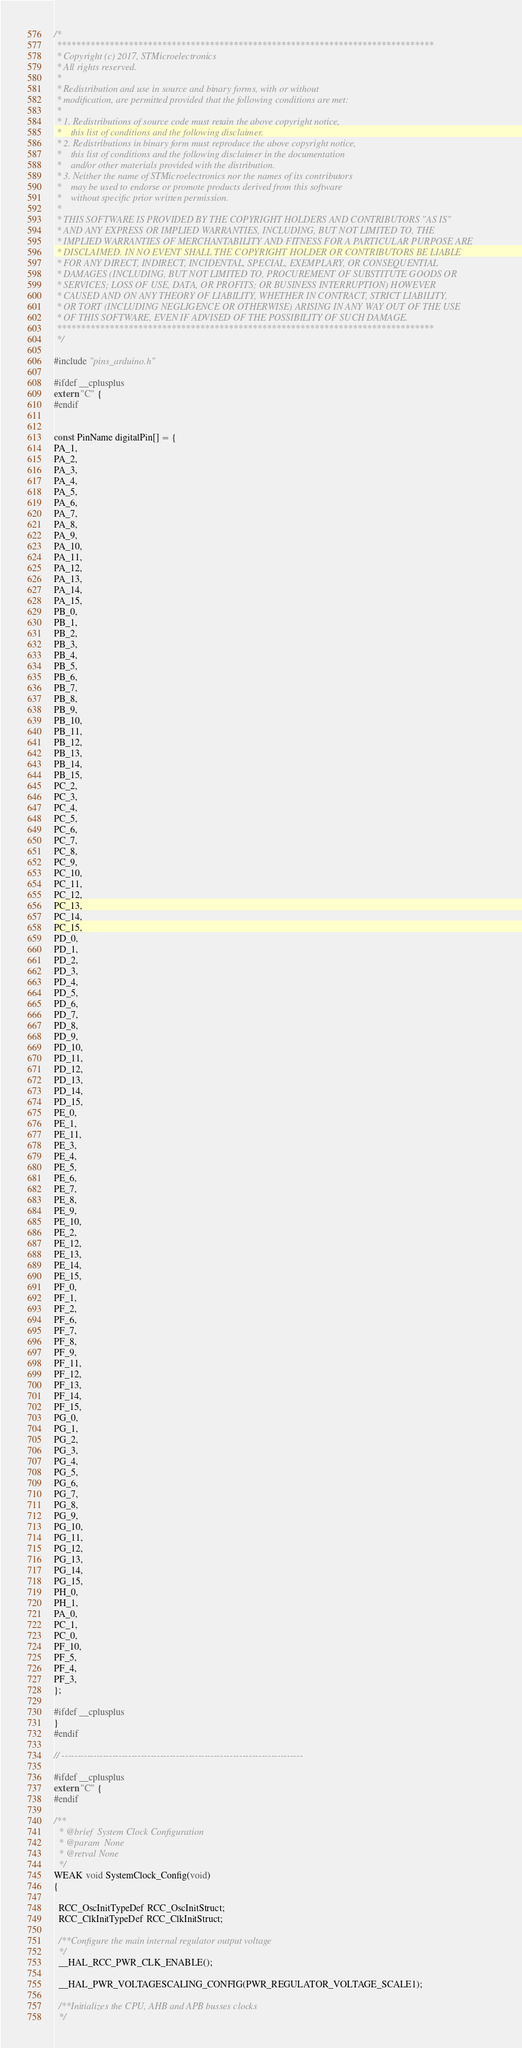<code> <loc_0><loc_0><loc_500><loc_500><_C++_>/*
 *******************************************************************************
 * Copyright (c) 2017, STMicroelectronics
 * All rights reserved.
 *
 * Redistribution and use in source and binary forms, with or without
 * modification, are permitted provided that the following conditions are met:
 *
 * 1. Redistributions of source code must retain the above copyright notice,
 *    this list of conditions and the following disclaimer.
 * 2. Redistributions in binary form must reproduce the above copyright notice,
 *    this list of conditions and the following disclaimer in the documentation
 *    and/or other materials provided with the distribution.
 * 3. Neither the name of STMicroelectronics nor the names of its contributors
 *    may be used to endorse or promote products derived from this software
 *    without specific prior written permission.
 *
 * THIS SOFTWARE IS PROVIDED BY THE COPYRIGHT HOLDERS AND CONTRIBUTORS "AS IS"
 * AND ANY EXPRESS OR IMPLIED WARRANTIES, INCLUDING, BUT NOT LIMITED TO, THE
 * IMPLIED WARRANTIES OF MERCHANTABILITY AND FITNESS FOR A PARTICULAR PURPOSE ARE
 * DISCLAIMED. IN NO EVENT SHALL THE COPYRIGHT HOLDER OR CONTRIBUTORS BE LIABLE
 * FOR ANY DIRECT, INDIRECT, INCIDENTAL, SPECIAL, EXEMPLARY, OR CONSEQUENTIAL
 * DAMAGES (INCLUDING, BUT NOT LIMITED TO, PROCUREMENT OF SUBSTITUTE GOODS OR
 * SERVICES; LOSS OF USE, DATA, OR PROFITS; OR BUSINESS INTERRUPTION) HOWEVER
 * CAUSED AND ON ANY THEORY OF LIABILITY, WHETHER IN CONTRACT, STRICT LIABILITY,
 * OR TORT (INCLUDING NEGLIGENCE OR OTHERWISE) ARISING IN ANY WAY OUT OF THE USE
 * OF THIS SOFTWARE, EVEN IF ADVISED OF THE POSSIBILITY OF SUCH DAMAGE.
 *******************************************************************************
 */

#include "pins_arduino.h"

#ifdef __cplusplus
extern "C" {
#endif


const PinName digitalPin[] = {
PA_1,
PA_2,
PA_3,
PA_4,
PA_5,
PA_6,
PA_7,
PA_8,
PA_9,
PA_10,
PA_11,
PA_12,
PA_13,
PA_14,
PA_15,
PB_0,
PB_1,
PB_2,
PB_3,
PB_4,
PB_5,
PB_6,
PB_7,
PB_8,
PB_9,
PB_10,
PB_11,
PB_12,
PB_13,
PB_14,
PB_15,
PC_2,
PC_3,
PC_4,
PC_5,
PC_6,
PC_7,
PC_8,
PC_9,
PC_10,
PC_11,
PC_12,
PC_13,
PC_14,
PC_15,
PD_0,
PD_1,
PD_2,
PD_3,
PD_4,
PD_5,
PD_6,
PD_7,
PD_8,
PD_9,
PD_10,
PD_11,
PD_12,
PD_13,
PD_14,
PD_15,
PE_0,
PE_1,
PE_11,
PE_3,
PE_4,
PE_5,
PE_6,
PE_7,
PE_8,
PE_9,
PE_10,
PE_2,
PE_12,
PE_13,
PE_14,
PE_15,
PF_0,
PF_1,
PF_2,
PF_6,
PF_7,
PF_8,
PF_9,
PF_11,
PF_12,
PF_13,
PF_14,
PF_15,
PG_0,
PG_1,
PG_2,
PG_3,
PG_4,
PG_5,
PG_6,
PG_7,
PG_8,
PG_9,
PG_10,
PG_11,
PG_12,
PG_13,
PG_14,
PG_15,
PH_0,
PH_1,
PA_0,
PC_1,
PC_0,
PF_10,
PF_5,
PF_4,
PF_3,
};

#ifdef __cplusplus
}
#endif

// ----------------------------------------------------------------------------

#ifdef __cplusplus
extern "C" {
#endif

/**
  * @brief  System Clock Configuration
  * @param  None
  * @retval None
  */
WEAK void SystemClock_Config(void)
{

  RCC_OscInitTypeDef RCC_OscInitStruct;
  RCC_ClkInitTypeDef RCC_ClkInitStruct;

  /**Configure the main internal regulator output voltage
  */
  __HAL_RCC_PWR_CLK_ENABLE();

  __HAL_PWR_VOLTAGESCALING_CONFIG(PWR_REGULATOR_VOLTAGE_SCALE1);

  /**Initializes the CPU, AHB and APB busses clocks
  */</code> 